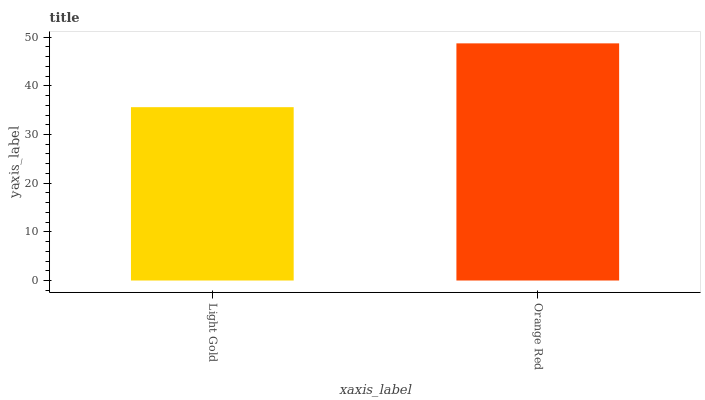Is Light Gold the minimum?
Answer yes or no. Yes. Is Orange Red the maximum?
Answer yes or no. Yes. Is Orange Red the minimum?
Answer yes or no. No. Is Orange Red greater than Light Gold?
Answer yes or no. Yes. Is Light Gold less than Orange Red?
Answer yes or no. Yes. Is Light Gold greater than Orange Red?
Answer yes or no. No. Is Orange Red less than Light Gold?
Answer yes or no. No. Is Orange Red the high median?
Answer yes or no. Yes. Is Light Gold the low median?
Answer yes or no. Yes. Is Light Gold the high median?
Answer yes or no. No. Is Orange Red the low median?
Answer yes or no. No. 